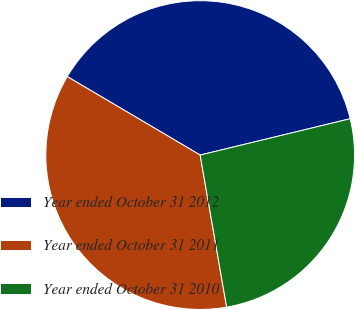Convert chart to OTSL. <chart><loc_0><loc_0><loc_500><loc_500><pie_chart><fcel>Year ended October 31 2012<fcel>Year ended October 31 2011<fcel>Year ended October 31 2010<nl><fcel>37.73%<fcel>36.23%<fcel>26.04%<nl></chart> 